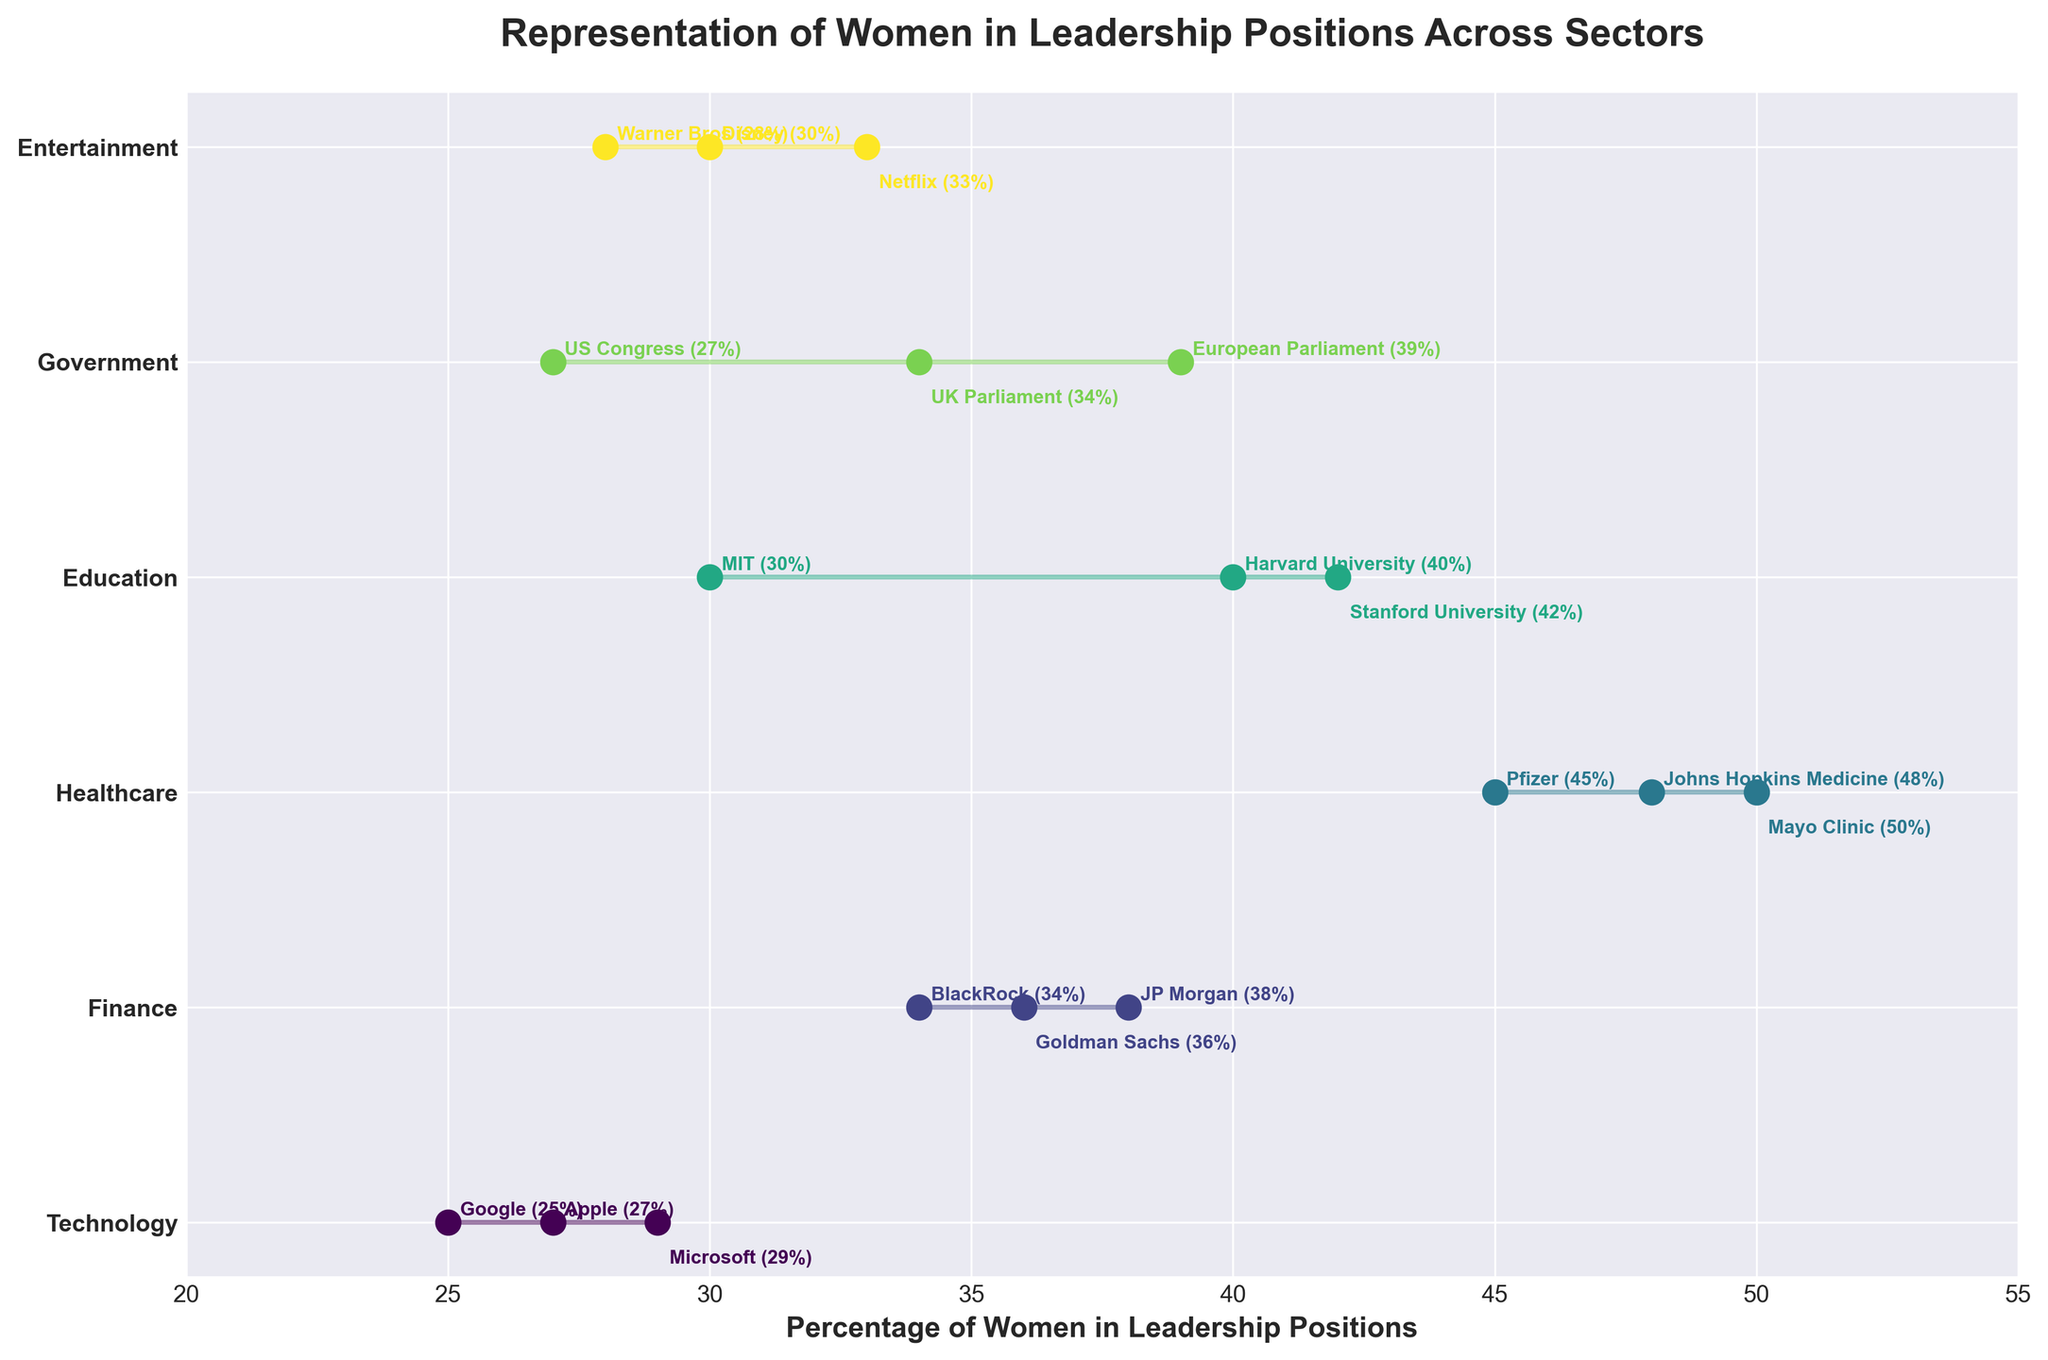How many sectors are represented in the plot? To determine the number of sectors, we count the unique labels on the y-axis. The sectors listed are Technology, Finance, Healthcare, Education, Government, and Entertainment.
Answer: 6 What is the title of the plot? The title of the plot is typically located at the top and center of the figure. It is "Representation of Women in Leadership Positions Across Sectors".
Answer: Representation of Women in Leadership Positions Across Sectors Which sector has the highest single percentage of women in leadership, and what is that percentage? To find the highest single percentage, look for the highest dot in each sector. The highest percentage is in the Healthcare sector, which is the Mayo Clinic at 50%.
Answer: Healthcare, 50% Which company in the Technology sector has the lowest percentage of women in leadership? By examining the plot for the Technology sector, the entity with the lowest percentage is Google, with 25%.
Answer: Google, 25% What is the average percentage of women in leadership across the entities in the Government sector? Calculate the average by summing the percentages (27 + 34 + 39) and dividing by the number of entities (3). This results in (27 + 34 + 39) / 3 = 33.33%.
Answer: 33.33% Compare the representation of women in leadership between the highest entity in the Technology sector and the lowest entity in the Entertainment sector. The highest in Technology is Microsoft at 29%, and the lowest in Entertainment is Warner Bros at 28%. Comparing these, Microsoft has a slightly higher percentage.
Answer: Microsoft, 29% vs. Warner Bros, 28% What is the range of the percentage of women in leadership positions in the Finance sector? To find the range, subtract the smallest percentage from the largest percentage in the Finance sector. The range is 38 (JP Morgan) - 34 (BlackRock) = 4.
Answer: 4 Which sector shows the most variation in the representation of women in leadership positions? The sector with the broadest range between the smallest and largest percentages is the Healthcare sector, ranging from 45% to 50%, a difference of 5.
Answer: Healthcare Identify a sector where all entities have women's representation in leadership within a 5% range from each other. The Finance sector with entities percentages of (38, 36, 34) all within a 4% range of each other.
Answer: Finance Is there any sector where the lowest representation in leadership exceeds the highest representation in the Technology sector? The lowest representation in Healthcare, 45%, exceeds the highest in Technology, 29%.
Answer: Yes 